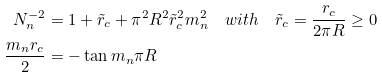Convert formula to latex. <formula><loc_0><loc_0><loc_500><loc_500>N _ { n } ^ { - 2 } & = 1 + \tilde { r } _ { c } + \pi ^ { 2 } R ^ { 2 } \tilde { r } _ { c } ^ { 2 } m _ { n } ^ { 2 } \quad w i t h \quad \tilde { r } _ { c } = \frac { r _ { c } } { 2 \pi R } \geq 0 \\ \frac { m _ { n } r _ { c } } { 2 } & = - \tan m _ { n } \pi R</formula> 